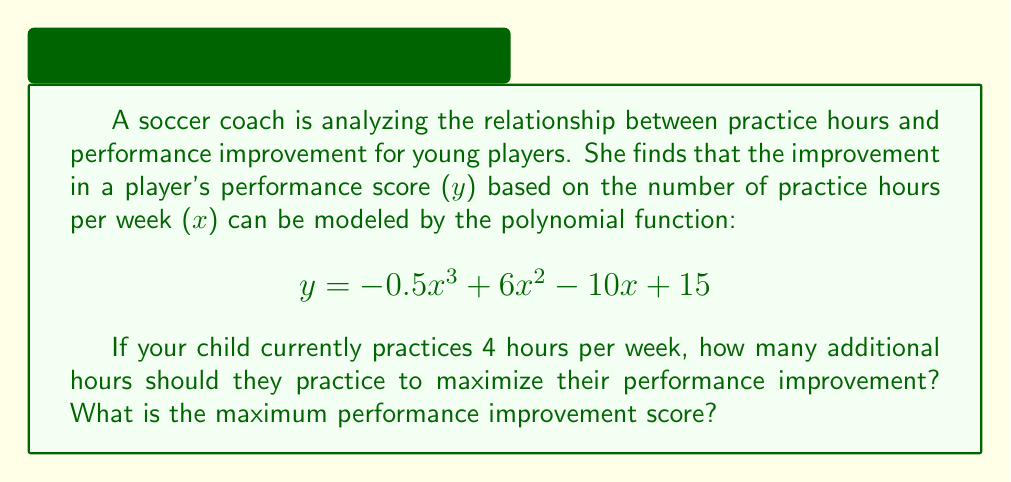Show me your answer to this math problem. To solve this problem, we need to find the maximum point of the given polynomial function. This can be done by following these steps:

1. Find the derivative of the function:
   $$\frac{dy}{dx} = -1.5x^2 + 12x - 10$$

2. Set the derivative equal to zero and solve for x:
   $$-1.5x^2 + 12x - 10 = 0$$
   
   This is a quadratic equation. We can solve it using the quadratic formula:
   $$x = \frac{-b \pm \sqrt{b^2 - 4ac}}{2a}$$
   
   Where $a = -1.5$, $b = 12$, and $c = -10$

   $$x = \frac{-12 \pm \sqrt{12^2 - 4(-1.5)(-10)}}{2(-1.5)}$$
   $$x = \frac{-12 \pm \sqrt{144 - 60}}{-3}$$
   $$x = \frac{-12 \pm \sqrt{84}}{-3}$$
   $$x = \frac{-12 \pm 9.17}{-3}$$

   This gives us two solutions:
   $x_1 = \frac{-12 + 9.17}{-3} = 0.94$
   $x_2 = \frac{-12 - 9.17}{-3} = 7.06$

3. The second solution, $x = 7.06$, is the maximum point because the coefficient of $x^3$ in the original function is negative.

4. To find the additional hours needed, subtract the current practice hours:
   Additional hours = 7.06 - 4 = 3.06 hours

5. To find the maximum performance improvement score, plug x = 7.06 into the original function:
   $$y = -0.5(7.06)^3 + 6(7.06)^2 - 10(7.06) + 15$$
   $$y = -175.91 + 299.06 - 70.6 + 15$$
   $$y = 67.55$$
Answer: Your child should practice an additional 3.06 hours per week (rounded to 3.1 hours) to maximize their performance improvement. The maximum performance improvement score is 67.55. 